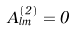Convert formula to latex. <formula><loc_0><loc_0><loc_500><loc_500>A _ { l m } ^ { ( 2 ) } = 0</formula> 